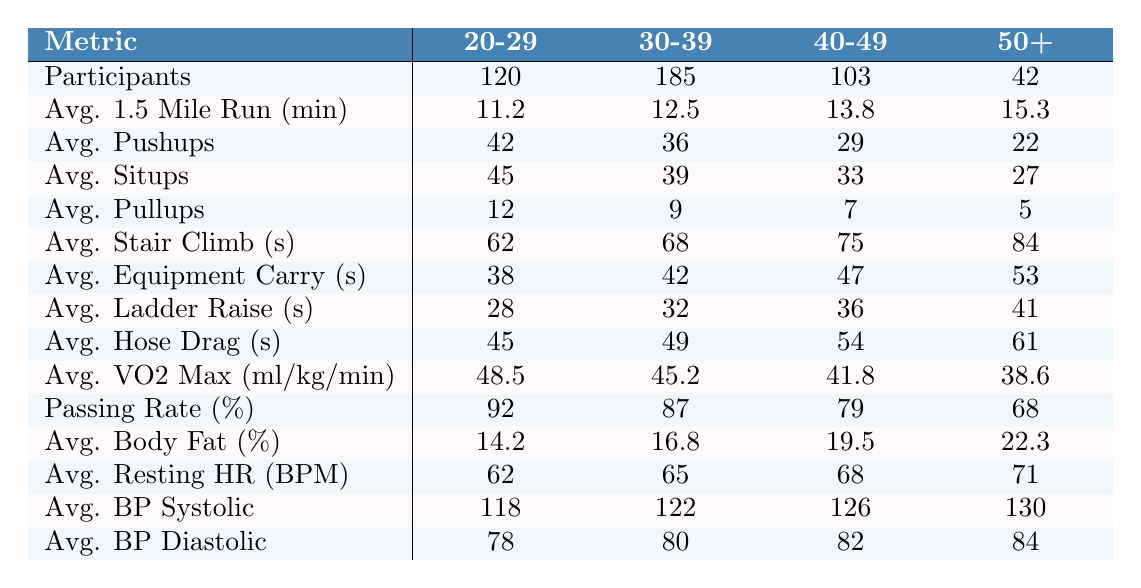What is the average 1.5-mile run time for the 30-39 age group? The average run time for the 30-39 age group is listed in the table under the category "Avg. 1.5 Mile Run (min)", which shows it as 12.5 minutes.
Answer: 12.5 minutes How many participants are in the 50+ age group? The number of participants in the 50+ age group can be found under the "Participants" column, where it states there are 42 participants.
Answer: 42 What is the passing rate for the 40-49 age group? The passing rate for the 40-49 age group is indicated in the "Passing Rate (%)" row, which shows it as 79 percent.
Answer: 79 percent Which age group has the highest average number of pushups? By comparing the average pushups count across all age groups, the 20-29 age group has the highest average at 42 pushups.
Answer: 20-29 age group Calculate the difference in average VO2 Max between the 20-29 and 50+ age groups. The average VO2 Max for the 20-29 age group is 48.5 and for the 50+ age group is 38.6. The difference is 48.5 - 38.6 = 9.9.
Answer: 9.9 Does the average resting heart rate increase with age? By examining the "Avg. Resting HR (BPM)" values for each age group, it is observed that the values increase: 62, 65, 68, and 71 for the respective groups, confirming that it does increase.
Answer: Yes What is the average equipment carry time for ages 30-39 and 50+ combined? The average equipment carry time for 30-39 is 42 seconds and for 50+ is 53 seconds. To find the average of these, add them together (42 + 53 = 95 seconds) and divide by 2 giving 95 / 2 = 47.5 seconds.
Answer: 47.5 seconds Which age group has the lowest average body fat percentage? The lowest average body fat percentage can be found in the "Avg. Body Fat (%)" row, where it is 14.2 percent for the 20-29 age group.
Answer: 20-29 age group How does the average ladder raise time change from the 30-39 age group to the 40-49 age group? The average ladder raise time for 30-39 is 32 seconds, and for 40-49 it is 36 seconds, indicating an increase of 36 - 32 = 4 seconds as we move to the older age group.
Answer: Increased by 4 seconds Is there a negative trend in pullup counts as age increases? By comparing the "Avg. Pullups" row values (12, 9, 7, 5), it shows a decreasing trend with increasing age, confirming a negative trend in pullup counts.
Answer: Yes 